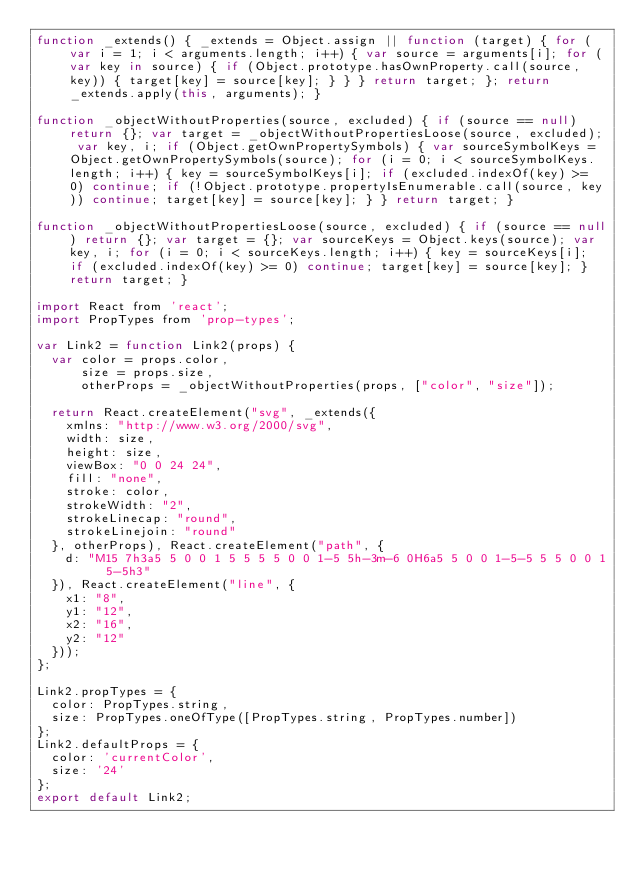Convert code to text. <code><loc_0><loc_0><loc_500><loc_500><_JavaScript_>function _extends() { _extends = Object.assign || function (target) { for (var i = 1; i < arguments.length; i++) { var source = arguments[i]; for (var key in source) { if (Object.prototype.hasOwnProperty.call(source, key)) { target[key] = source[key]; } } } return target; }; return _extends.apply(this, arguments); }

function _objectWithoutProperties(source, excluded) { if (source == null) return {}; var target = _objectWithoutPropertiesLoose(source, excluded); var key, i; if (Object.getOwnPropertySymbols) { var sourceSymbolKeys = Object.getOwnPropertySymbols(source); for (i = 0; i < sourceSymbolKeys.length; i++) { key = sourceSymbolKeys[i]; if (excluded.indexOf(key) >= 0) continue; if (!Object.prototype.propertyIsEnumerable.call(source, key)) continue; target[key] = source[key]; } } return target; }

function _objectWithoutPropertiesLoose(source, excluded) { if (source == null) return {}; var target = {}; var sourceKeys = Object.keys(source); var key, i; for (i = 0; i < sourceKeys.length; i++) { key = sourceKeys[i]; if (excluded.indexOf(key) >= 0) continue; target[key] = source[key]; } return target; }

import React from 'react';
import PropTypes from 'prop-types';

var Link2 = function Link2(props) {
  var color = props.color,
      size = props.size,
      otherProps = _objectWithoutProperties(props, ["color", "size"]);

  return React.createElement("svg", _extends({
    xmlns: "http://www.w3.org/2000/svg",
    width: size,
    height: size,
    viewBox: "0 0 24 24",
    fill: "none",
    stroke: color,
    strokeWidth: "2",
    strokeLinecap: "round",
    strokeLinejoin: "round"
  }, otherProps), React.createElement("path", {
    d: "M15 7h3a5 5 0 0 1 5 5 5 5 0 0 1-5 5h-3m-6 0H6a5 5 0 0 1-5-5 5 5 0 0 1 5-5h3"
  }), React.createElement("line", {
    x1: "8",
    y1: "12",
    x2: "16",
    y2: "12"
  }));
};

Link2.propTypes = {
  color: PropTypes.string,
  size: PropTypes.oneOfType([PropTypes.string, PropTypes.number])
};
Link2.defaultProps = {
  color: 'currentColor',
  size: '24'
};
export default Link2;</code> 